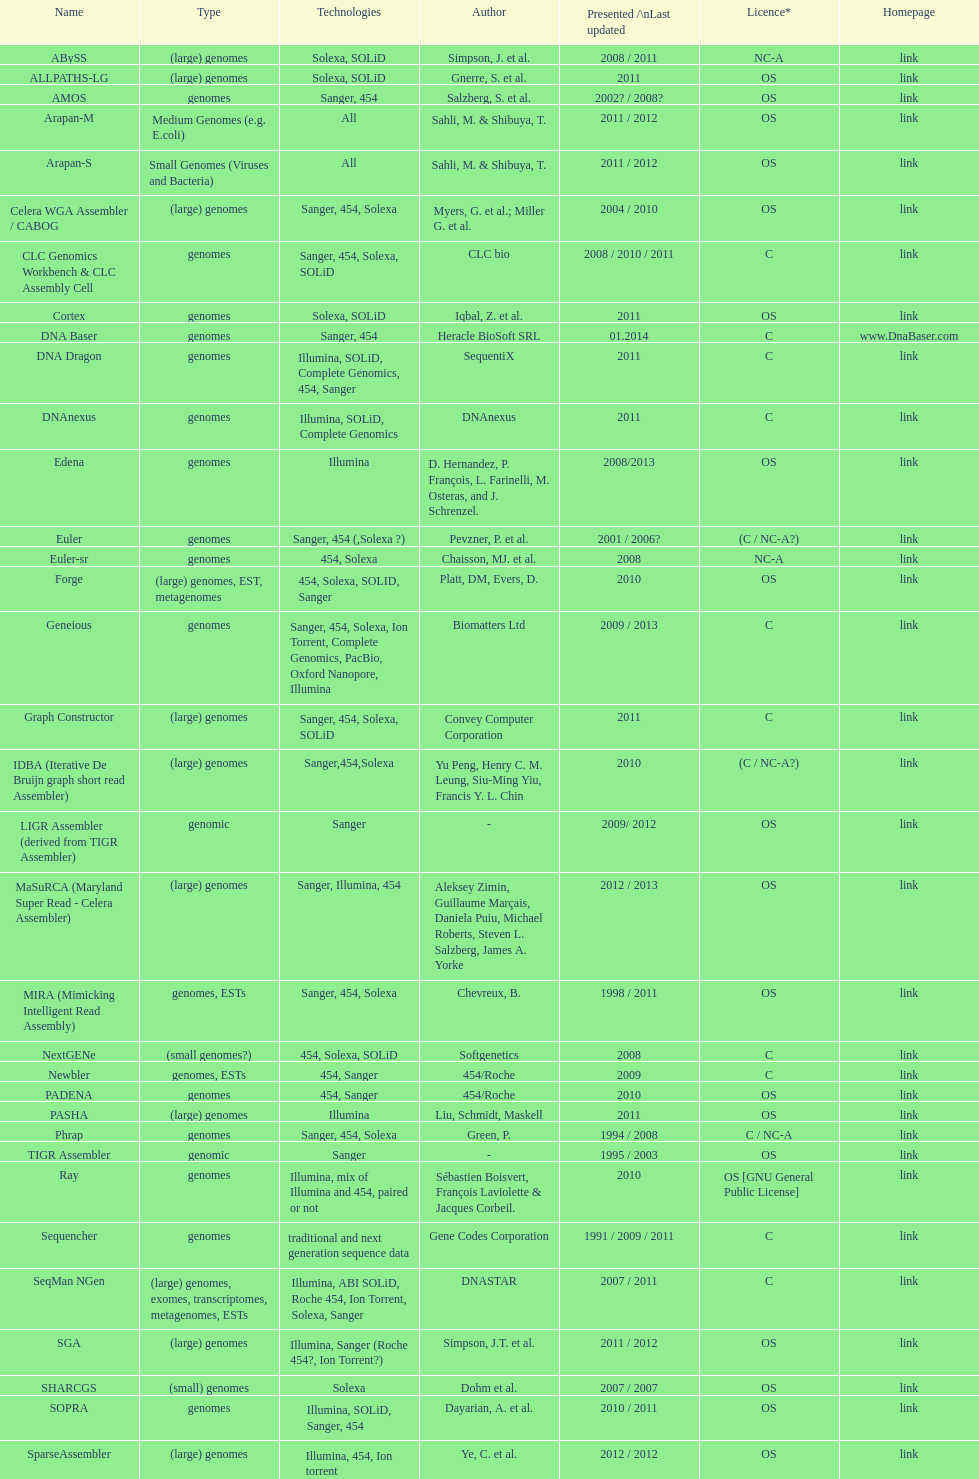When did the velvet receive its latest update? 2009. 